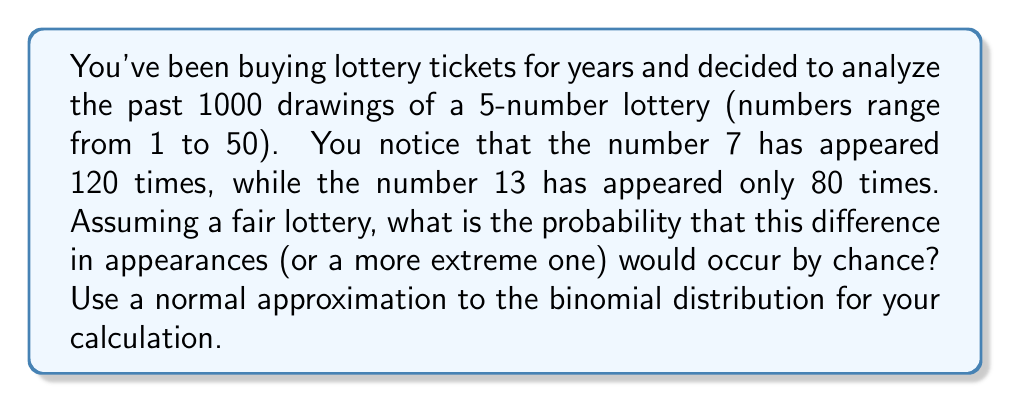Provide a solution to this math problem. Let's approach this step-by-step:

1) In a fair 5-number lottery with 50 possible numbers, the probability of any number being drawn in a single drawing is:

   $p = \frac{5}{50} = 0.1$

2) For 1000 drawings, the expected number of times any number should appear is:

   $\mu = np = 1000 * 0.1 = 100$

3) The variance of a binomial distribution is:

   $\sigma^2 = np(1-p) = 1000 * 0.1 * 0.9 = 90$

4) The standard deviation is:

   $\sigma = \sqrt{90} = 9.487$

5) We're interested in the difference between two numbers' appearances. The variance of this difference is twice the variance of a single number:

   $\sigma_{diff}^2 = 2 * 90 = 180$

   $\sigma_{diff} = \sqrt{180} = 13.416$

6) The observed difference is 120 - 80 = 40. We need to calculate the z-score:

   $z = \frac{|40 - 0|}{\sigma_{diff}} = \frac{40}{13.416} = 2.981$

7) Using the normal distribution, the probability of getting a z-score of 2.981 or more extreme (two-tailed test) is:

   $P(|Z| > 2.981) = 2 * (1 - \Phi(2.981))$

   where $\Phi$ is the cumulative distribution function of the standard normal distribution.

8) Using a standard normal table or calculator, we find:

   $2 * (1 - \Phi(2.981)) \approx 0.00287$
Answer: 0.00287 